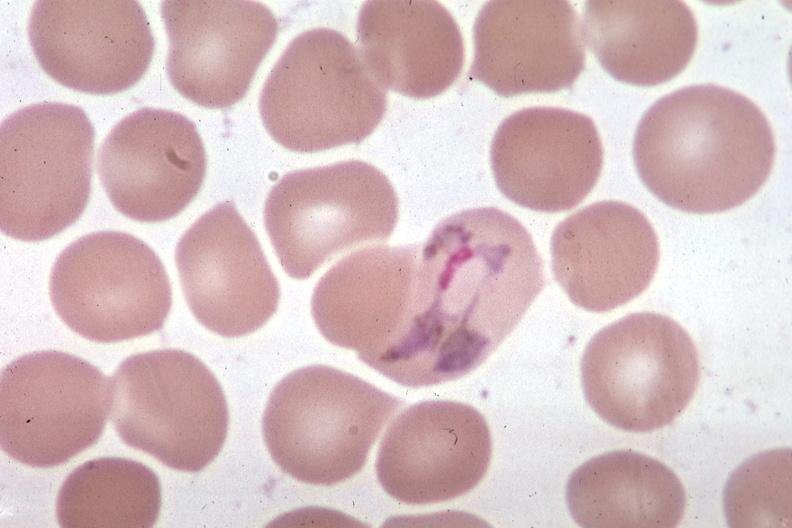s malaria plasmodium vivax present?
Answer the question using a single word or phrase. Yes 